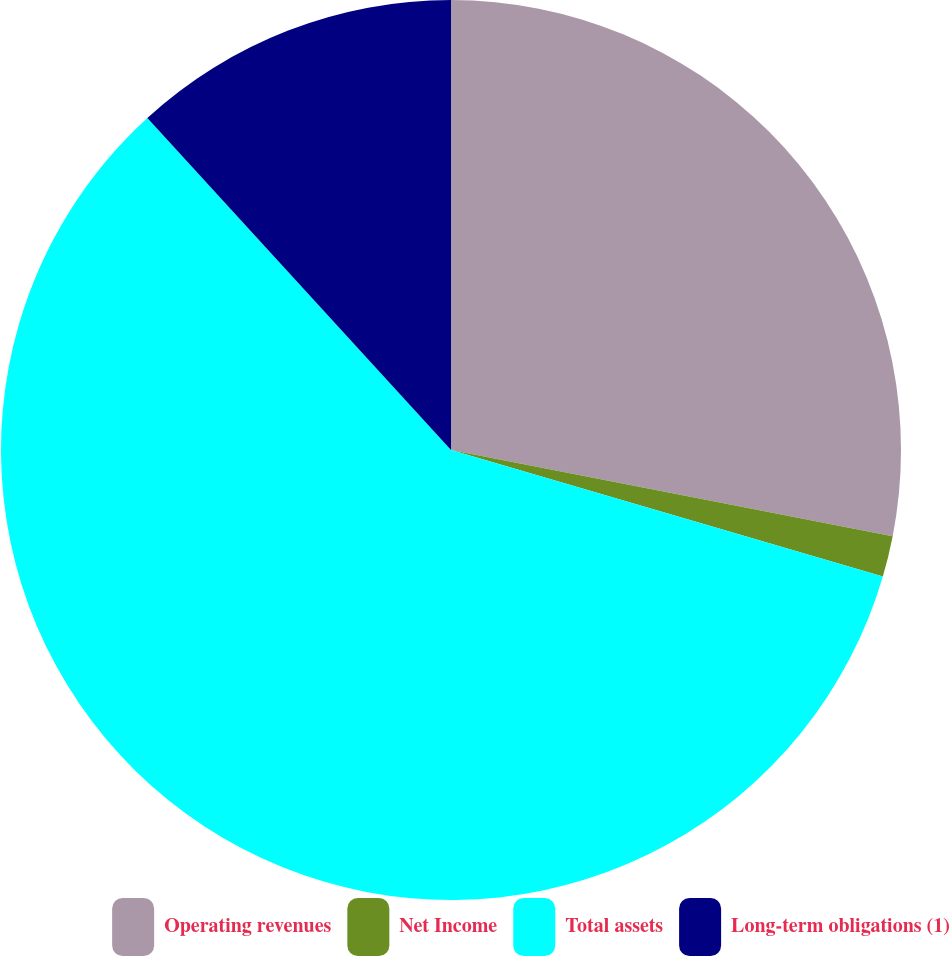<chart> <loc_0><loc_0><loc_500><loc_500><pie_chart><fcel>Operating revenues<fcel>Net Income<fcel>Total assets<fcel>Long-term obligations (1)<nl><fcel>28.07%<fcel>1.47%<fcel>58.68%<fcel>11.79%<nl></chart> 